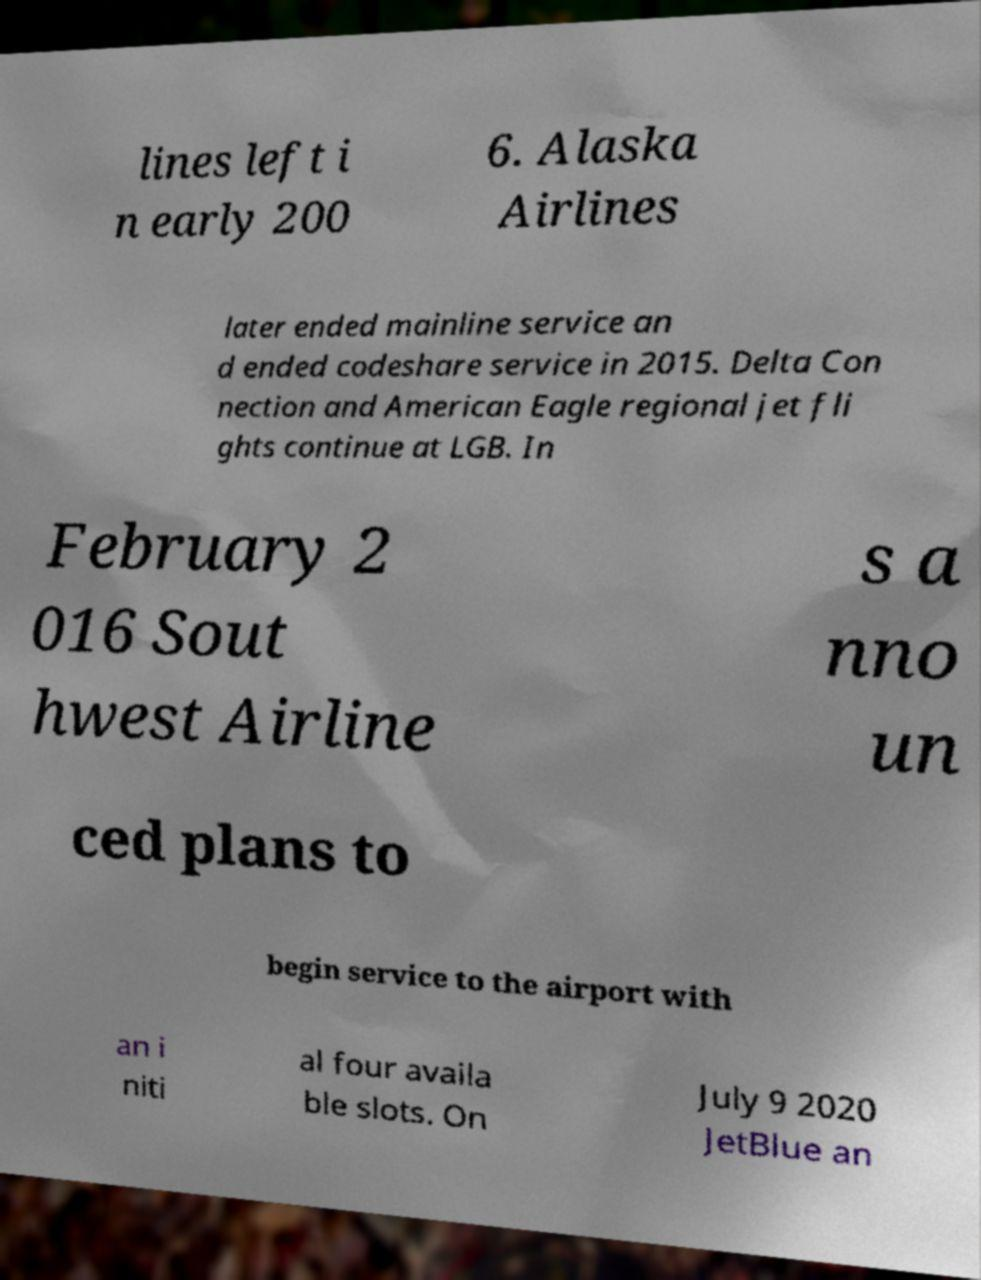For documentation purposes, I need the text within this image transcribed. Could you provide that? lines left i n early 200 6. Alaska Airlines later ended mainline service an d ended codeshare service in 2015. Delta Con nection and American Eagle regional jet fli ghts continue at LGB. In February 2 016 Sout hwest Airline s a nno un ced plans to begin service to the airport with an i niti al four availa ble slots. On July 9 2020 JetBlue an 